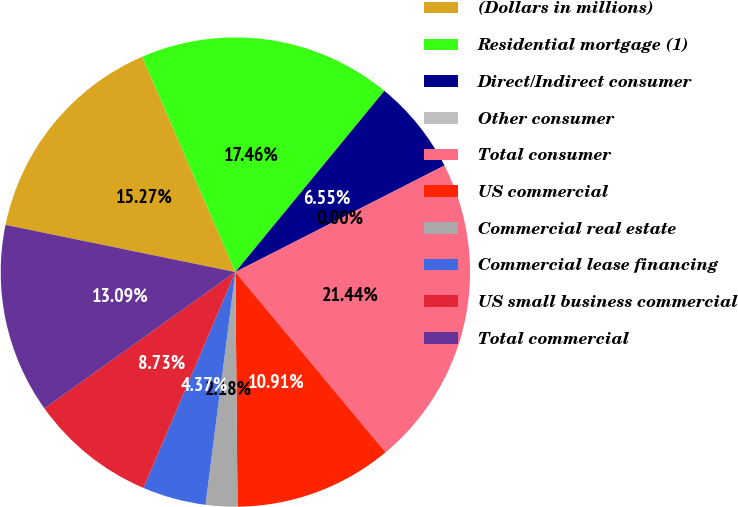Convert chart. <chart><loc_0><loc_0><loc_500><loc_500><pie_chart><fcel>(Dollars in millions)<fcel>Residential mortgage (1)<fcel>Direct/Indirect consumer<fcel>Other consumer<fcel>Total consumer<fcel>US commercial<fcel>Commercial real estate<fcel>Commercial lease financing<fcel>US small business commercial<fcel>Total commercial<nl><fcel>15.27%<fcel>17.46%<fcel>6.55%<fcel>0.0%<fcel>21.44%<fcel>10.91%<fcel>2.18%<fcel>4.37%<fcel>8.73%<fcel>13.09%<nl></chart> 